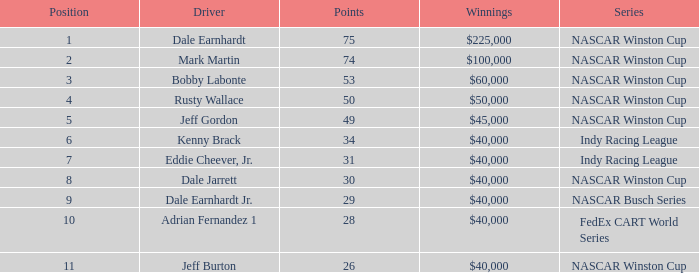How much did Kenny Brack win? $40,000. 